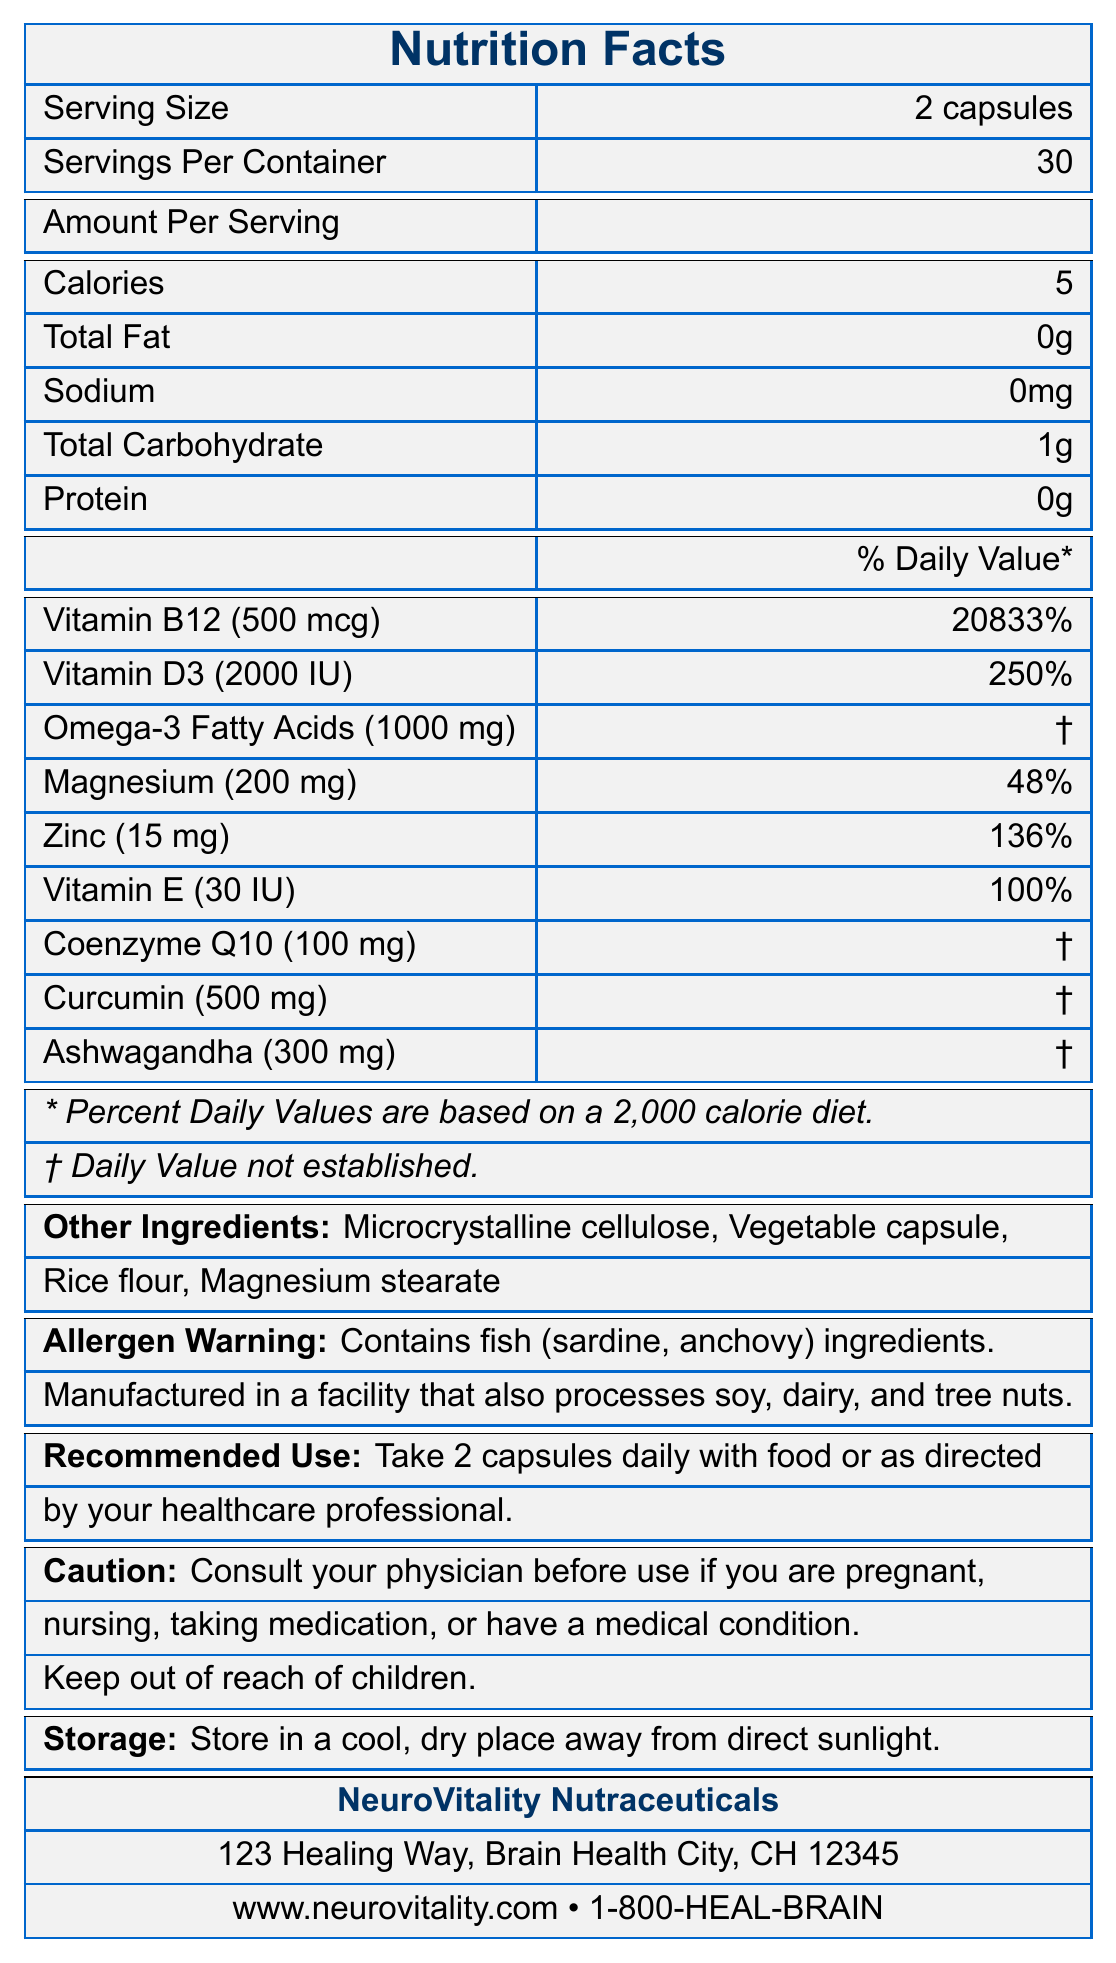What is the serving size of the supplement? The serving size information is listed at the top of the document as "Serving Size: 2 capsules."
Answer: 2 capsules How many capsules are in one container? The document states "Servings Per Container: 30" and each serving is "2 capsules," so 30 servings times 2 capsules per serving equals 60 capsules.
Answer: 60 capsules What is the percentage of Daily Value for Vitamin B12 per serving? The amount per serving for Vitamin B12 is listed as "500 mcg" with a percent daily value of 20833%.
Answer: 20833% What are the benefits of taking Vitamin D3? The document states that Vitamin D3 "Promotes neuroprotection and reduces inflammation."
Answer: Promotes neuroprotection and reduces inflammation Which ingredient helps enhance mitochondrial function in brain cells? The benefits of Coenzyme Q10 are listed as "Enhances mitochondrial function in brain cells."
Answer: Coenzyme Q10 What should you do before taking this supplement if you are pregnant? The cautionary note advises consulting a physician before use if pregnant.
Answer: Consult your physician Does this supplement contain any allergens? The allergen warning mentions that the supplement contains fish (sardine, anchovy) ingredients and advises caution for those with soy, dairy, and tree nut allergies.
Answer: Yes Which of the following does NOT act as an ingredient in this supplement? A. Microcrystalline cellulose B. Vegetable capsule C. Lactose D. Rice flour The document lists the ingredients as Microcrystalline cellulose, Vegetable capsule, Rice flour, and Magnesium stearate; Lactose is not on this list.
Answer: C. Lactose Which mineral in the supplement aids in neurotransmitter function and reduces excitotoxicity? A. Magnesium B. Zinc C. Iron D. Calcium The document specifies that Magnesium "Aids in neurotransmitter function and reduces excitotoxicity."
Answer: A. Magnesium Is the given information enough to determine the long-term effects of the supplement? The document does not provide any information about the long-term effects of the supplement, only the immediate benefits of each component.
Answer: No Summarize the information provided in the document. The document provides comprehensive details about the supplement's composition, usage, and safety information.
Answer: The document is a Nutrition Facts Label for a supplement by NeuroVitality Nutraceuticals designed to support neurological healing. It lists the serving size, servings per container, and the amount per serving for each component: calories, fat, sodium, carbohydrate, protein, and various vitamins and minerals along with their benefits. Additionally, it includes other ingredients, allergen warnings, recommended use, cautionary notes, storage instructions, and manufacturer information. What is the daily value percentage of Zinc per serving? The document shows that Zinc has a daily value percentage of 136% per serving.
Answer: 136% What are the benefits of curcumin in the supplement? The document states that curcumin "Reduces neuroinflammation and supports cognitive function."
Answer: Reduces neuroinflammation and supports cognitive function What is the recommended daily dose of the supplement? The recommended use section advises taking 2 capsules daily with food or as directed by a healthcare professional.
Answer: 2 capsules daily with food or as directed by your healthcare professional Could this product help in reducing oxidative stress? A. Yes B. No The document mentions that Vitamin E in the supplement "Protects neurons from oxidative stress," implying that the product could help in reducing oxidative stress.
Answer: A. Yes What kind of warning is provided regarding the storage of the supplement? The storage instructions clearly state to store the supplement in a cool, dry place away from direct sunlight.
Answer: Store in a cool, dry place away from direct sunlight. What is the total carbohydrate content per serving of the supplement? The amount of total carbohydrate per serving is listed as 1 gram.
Answer: 1 gram Does the information mention how the product is manufactured? The allergen warning states that the product is manufactured in a facility that processes soy, dairy, and tree nuts, indicating it includes some information about the manufacturing process.
Answer: Yes What are some of the other ingredients in the supplement? The document lists additional ingredients under "Other Ingredients."
Answer: Microcrystalline cellulose, Vegetable capsule, Rice flour, Magnesium stearate Who manufactures this product? The manufacturer information mentions that the product is made by NeuroVitality Nutraceuticals.
Answer: NeuroVitality Nutraceuticals 